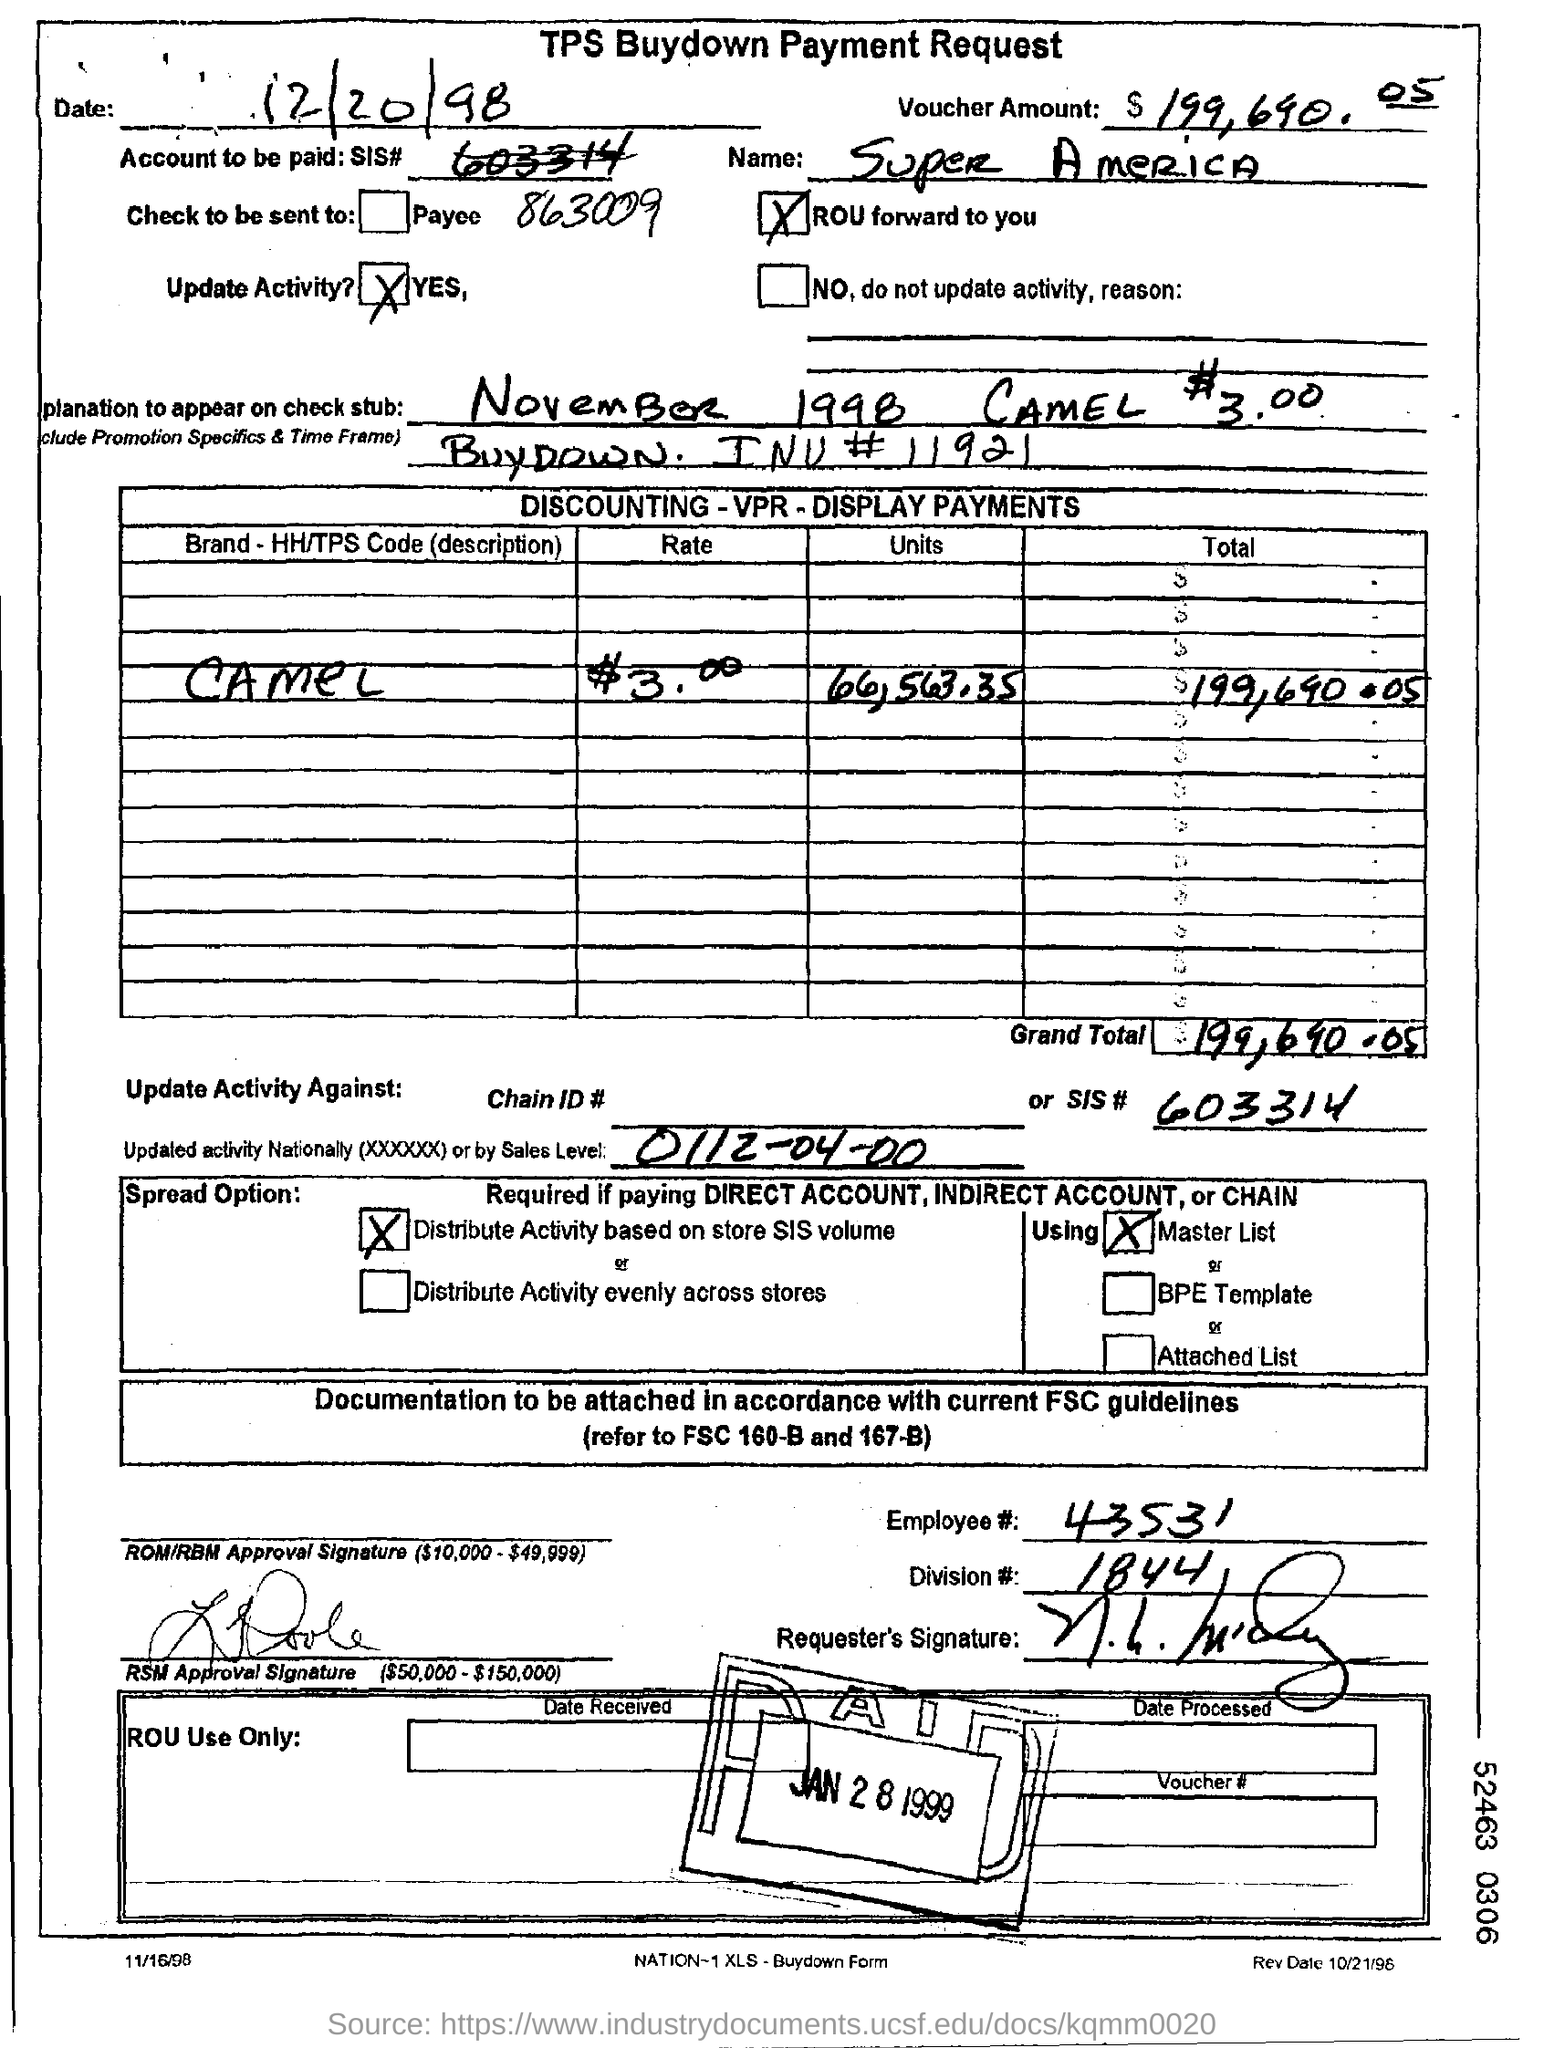Point out several critical features in this image. The date mentioned is December 20, 1998. The employee number mentioned in the form is 43531. The document in question is the TPS Buydown Payment Request. The table mentions the brand Camel. 